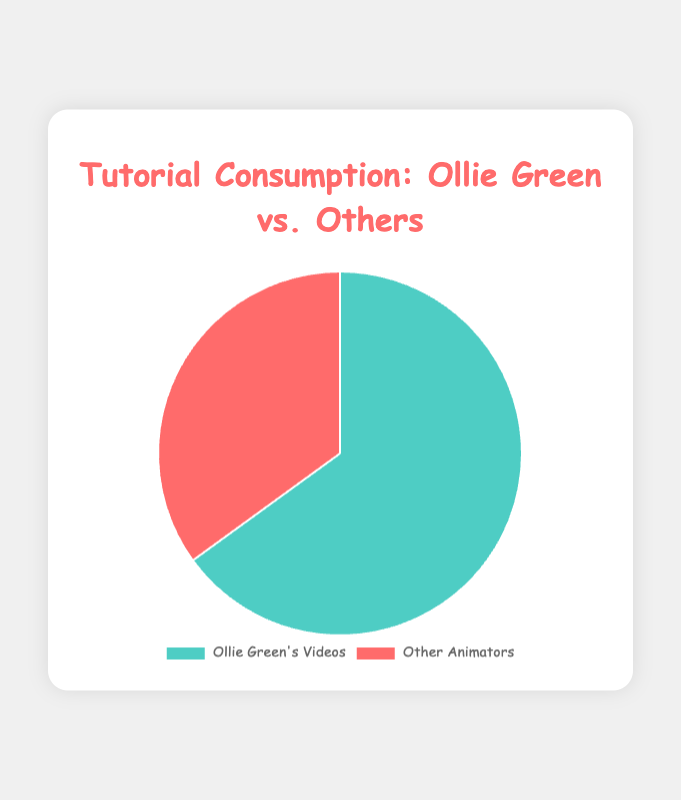What percentage of the total tutorial consumption is from Ollie Green's videos? From the chart, the segment representing Ollie Green's videos is labeled with 65%. This means that 65% of the total tutorial consumption is from his videos.
Answer: 65% What is the percentage difference between Ollie Green's videos and other animators? The chart shows that Ollie Green’s videos are 65% and other animators are 35%. The difference is found by subtracting the percentage of other animators from Ollie Green's videos: 65% - 35% = 30%.
Answer: 30% Which category has the higher percentage of tutorial consumption, and by how much? From the chart, Ollie Green's videos account for 65%, and other animators account for 35%. Ollie Green's videos have a higher percentage by 65% - 35% = 30%.
Answer: Ollie Green's videos by 30% What color represents the "Other Animators" category in the pie chart? The chart uses visual attributes where "Other Animators" is represented by red.
Answer: Red What proportion of the total tutorial consumption is related to other animators? From the chart, the percentage for other animators is given as 35%, indicating the proportion of tutorial consumption related to other animators.
Answer: 35% By how many times is the consumption of Ollie Green's videos greater than the consumption of other animators? To find this, divide the percentage of Ollie Green's videos by the percentage of other animators: 65% / 35% = 1.8571, which means Ollie Green's videos are consumed about 1.86 times more than other animators.
Answer: 1.86 times If 100 people were surveyed, how many would have watched Ollie Green's videos? If 65% of people watched Ollie Green’s videos, and 100 people were surveyed, the number of people is calculated as 65% of 100: 0.65 * 100 = 65 people.
Answer: 65 people 